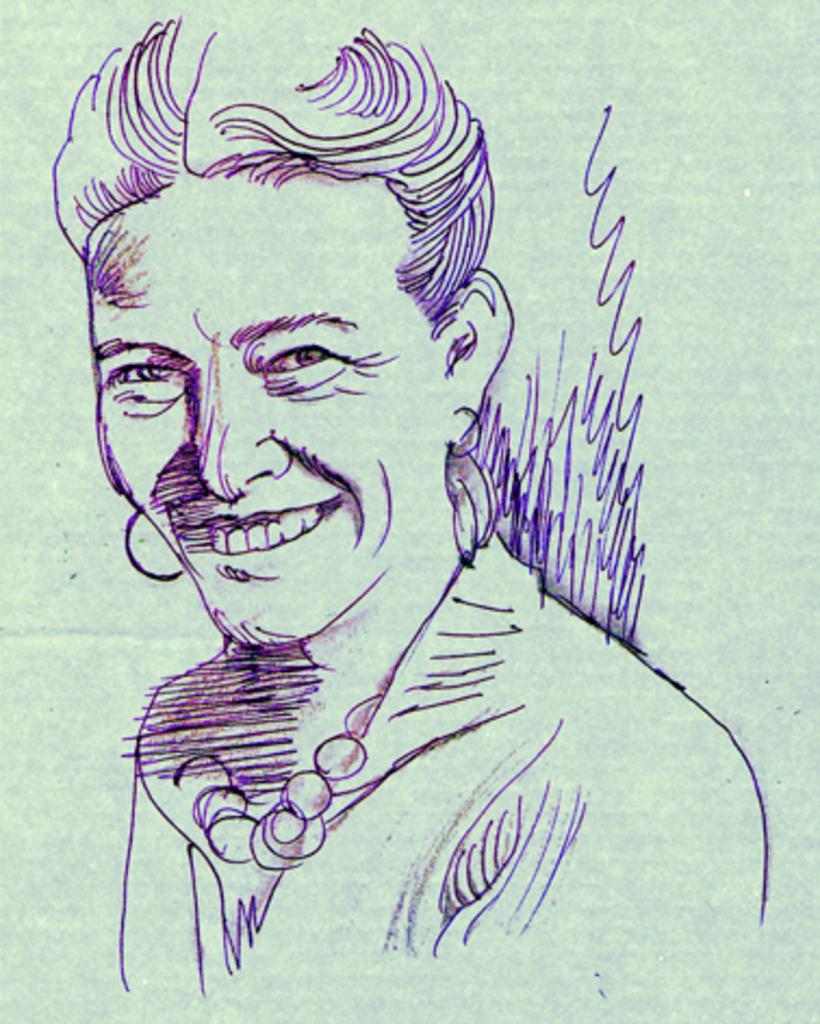What is depicted in the image? There is a sketch of a person in the image. Can you describe the facial expression of the person in the sketch? The person in the sketch is smiling. How many nails are visible in the image? There are no nails present in the image; it features a sketch of a person. Is the person in the sketch being attacked by any animals? There is no indication of an attack or any animals present in the image. 